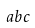Convert formula to latex. <formula><loc_0><loc_0><loc_500><loc_500>a b c</formula> 